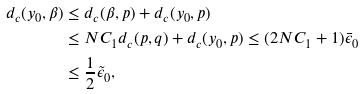Convert formula to latex. <formula><loc_0><loc_0><loc_500><loc_500>d _ { c } ( y _ { 0 } , \beta ) & \leq d _ { c } ( \beta , p ) + d _ { c } ( y _ { 0 } , p ) \\ & \leq N C _ { 1 } d _ { c } ( p , q ) + d _ { c } ( y _ { 0 } , p ) \leq ( 2 N C _ { 1 } + 1 ) \bar { \epsilon } _ { 0 } \\ & \leq \frac { 1 } { 2 } \tilde { \epsilon } _ { 0 } ,</formula> 